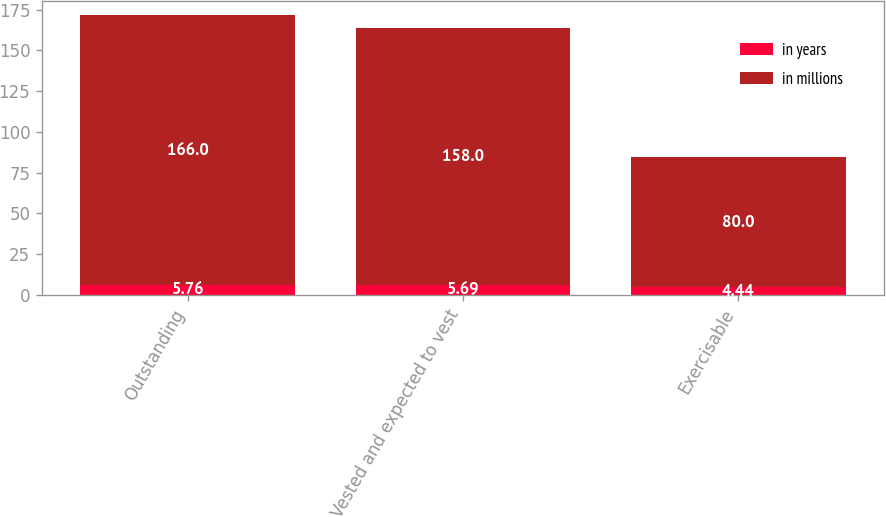Convert chart. <chart><loc_0><loc_0><loc_500><loc_500><stacked_bar_chart><ecel><fcel>Outstanding<fcel>Vested and expected to vest<fcel>Exercisable<nl><fcel>in years<fcel>5.76<fcel>5.69<fcel>4.44<nl><fcel>in millions<fcel>166<fcel>158<fcel>80<nl></chart> 